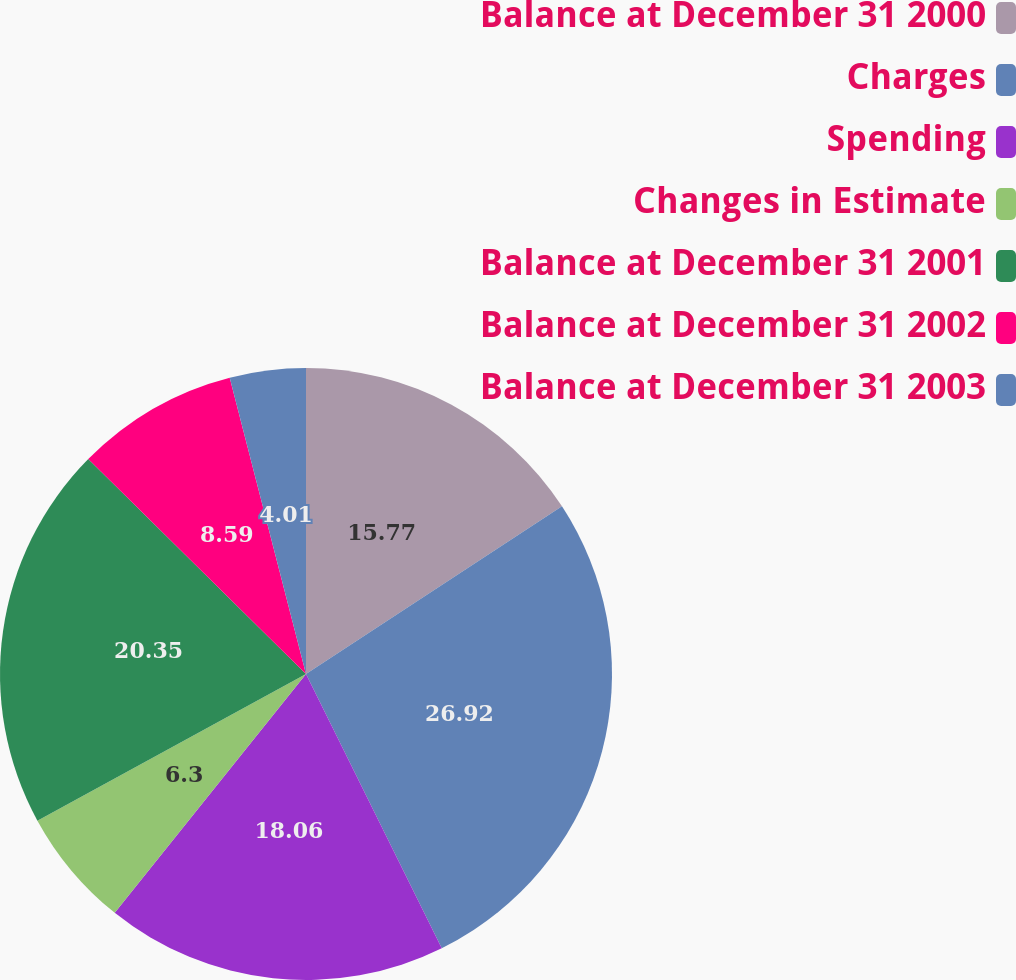<chart> <loc_0><loc_0><loc_500><loc_500><pie_chart><fcel>Balance at December 31 2000<fcel>Charges<fcel>Spending<fcel>Changes in Estimate<fcel>Balance at December 31 2001<fcel>Balance at December 31 2002<fcel>Balance at December 31 2003<nl><fcel>15.77%<fcel>26.91%<fcel>18.06%<fcel>6.3%<fcel>20.35%<fcel>8.59%<fcel>4.01%<nl></chart> 